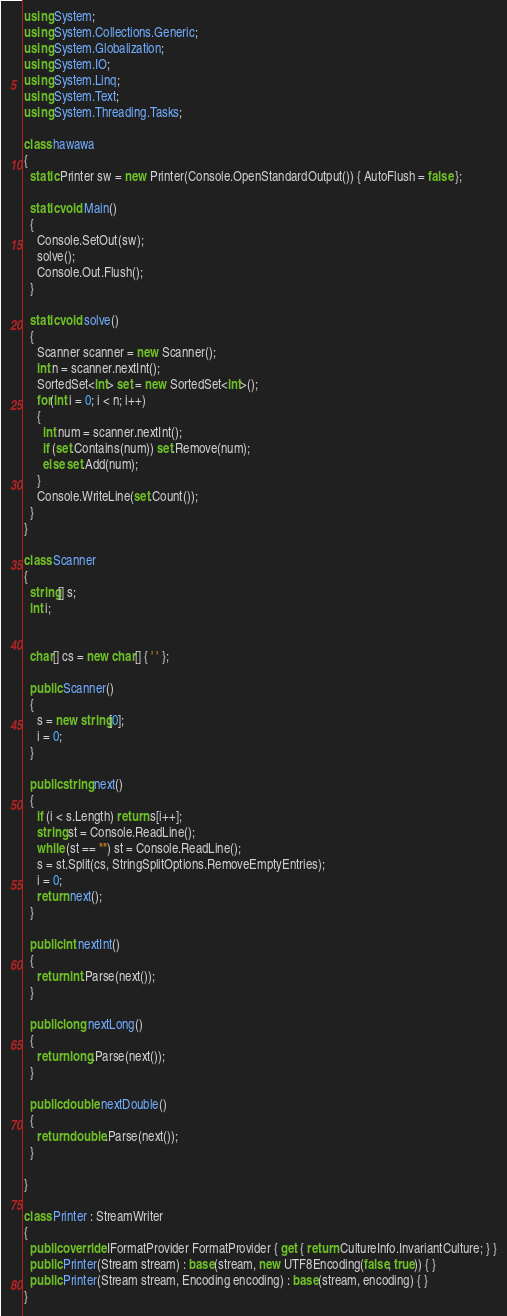<code> <loc_0><loc_0><loc_500><loc_500><_C#_>using System;
using System.Collections.Generic;
using System.Globalization;
using System.IO;
using System.Linq;
using System.Text;
using System.Threading.Tasks;

class hawawa
{
  static Printer sw = new Printer(Console.OpenStandardOutput()) { AutoFlush = false };

  static void Main()
  {
    Console.SetOut(sw);
    solve();
    Console.Out.Flush();
  }
  
  static void solve()
  {
    Scanner scanner = new Scanner();
    int n = scanner.nextInt();
    SortedSet<int> set = new SortedSet<int>();
    for(int i = 0; i < n; i++)
    {
      int num = scanner.nextInt();
      if (set.Contains(num)) set.Remove(num);
      else set.Add(num);
    }
    Console.WriteLine(set.Count());
  }
}

class Scanner
{
  string[] s;
  int i;


  char[] cs = new char[] { ' ' };

  public Scanner()
  {
    s = new string[0];
    i = 0;
  }

  public string next()
  {
    if (i < s.Length) return s[i++];
    string st = Console.ReadLine();
    while (st == "") st = Console.ReadLine();
    s = st.Split(cs, StringSplitOptions.RemoveEmptyEntries);
    i = 0;
    return next();
  }

  public int nextInt()
  {
    return int.Parse(next());
  }

  public long nextLong()
  {
    return long.Parse(next());
  }

  public double nextDouble()
  {
    return double.Parse(next());
  }

}

class Printer : StreamWriter
{
  public override IFormatProvider FormatProvider { get { return CultureInfo.InvariantCulture; } }
  public Printer(Stream stream) : base(stream, new UTF8Encoding(false, true)) { }
  public Printer(Stream stream, Encoding encoding) : base(stream, encoding) { }
}</code> 